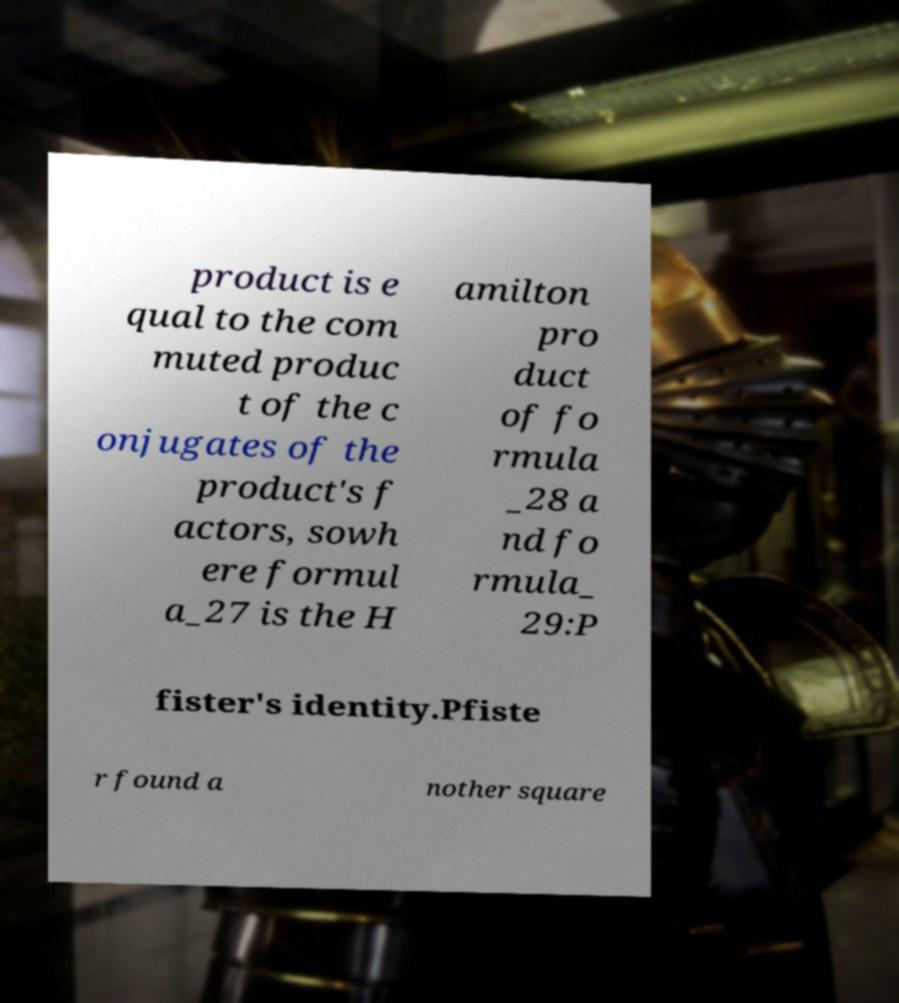For documentation purposes, I need the text within this image transcribed. Could you provide that? product is e qual to the com muted produc t of the c onjugates of the product's f actors, sowh ere formul a_27 is the H amilton pro duct of fo rmula _28 a nd fo rmula_ 29:P fister's identity.Pfiste r found a nother square 